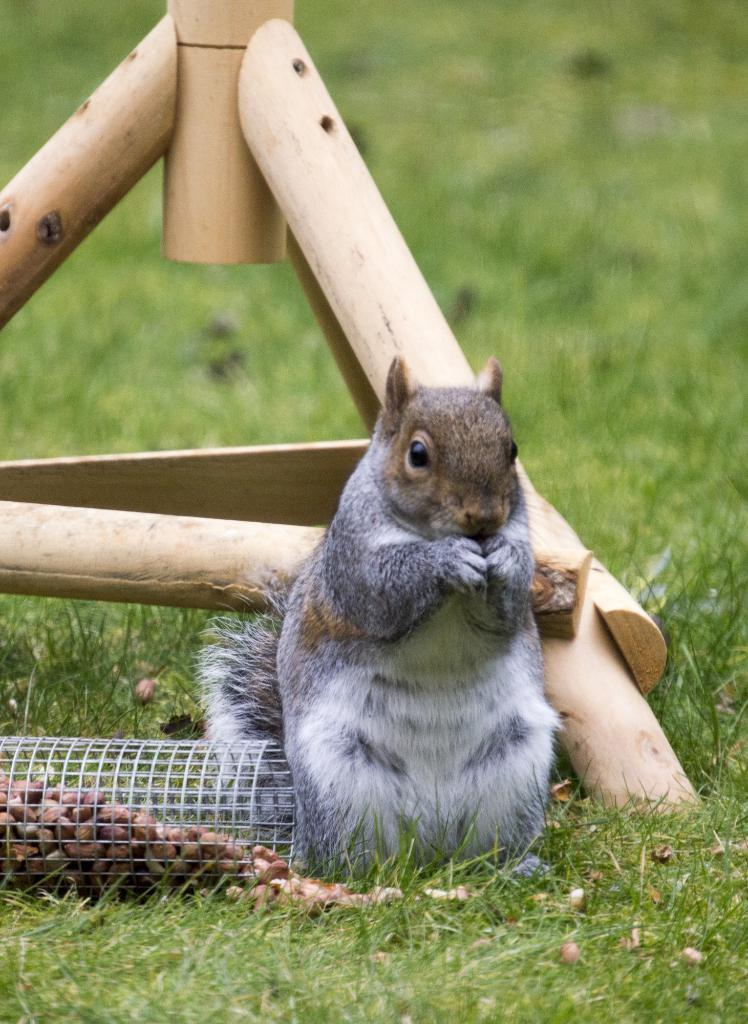What animal can be seen in the image? There is a squirrel in the image. Where is the squirrel located? The squirrel is standing on the grass. What is near the squirrel in the image? There are nuts in a welded wire mesh on the left side of the image. What can be seen in the background of the image? There is a wooden object and grass in the background of the image. What type of rice is being served during the recess in the image? There is no rice or recess present in the image; it features a squirrel standing on the grass with nuts nearby. 